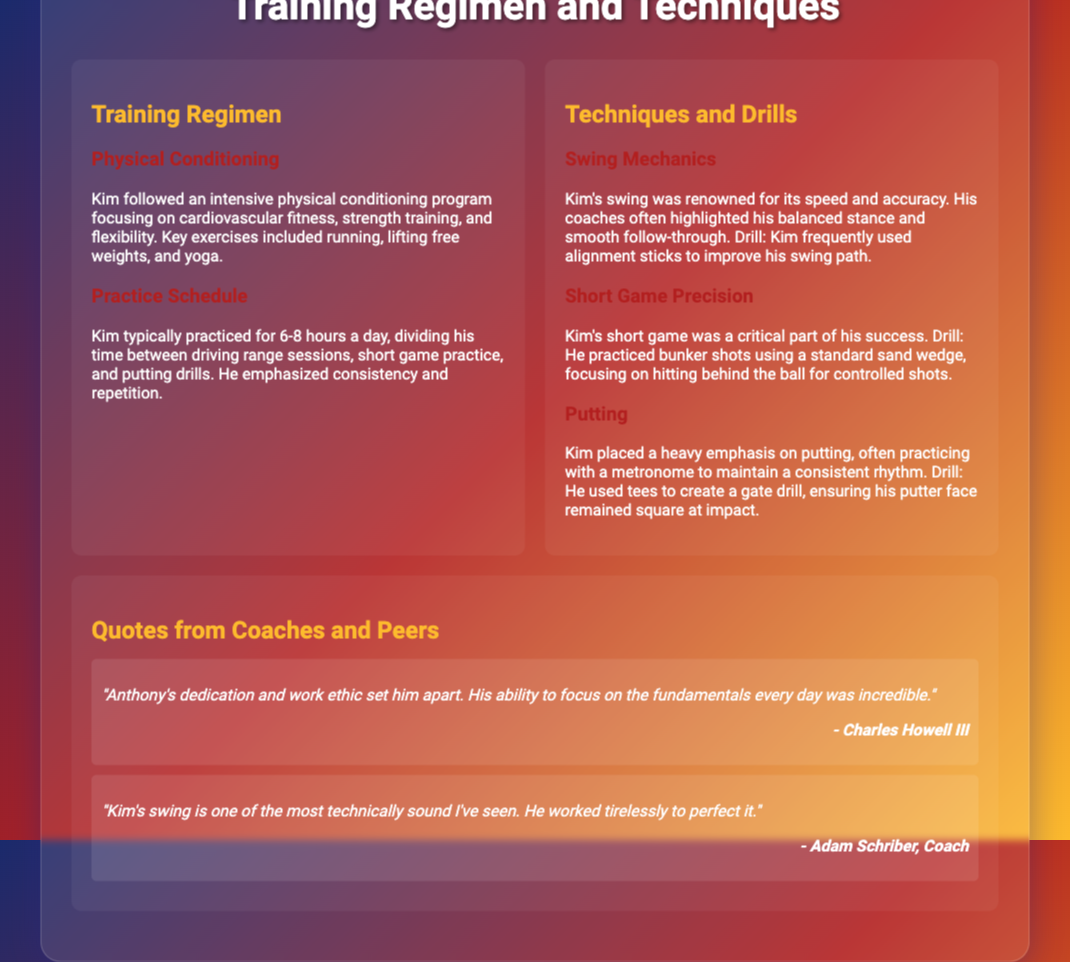What was the focus of Kim's physical conditioning program? The physical conditioning program focused on cardiovascular fitness, strength training, and flexibility.
Answer: Cardiovascular fitness, strength training, and flexibility How many hours did Kim typically practice in a day? Kim typically practiced for 6-8 hours a day.
Answer: 6-8 hours What technique did Kim frequently use to improve his swing path? Kim frequently used alignment sticks to improve his swing path.
Answer: Alignment sticks What is a critical part of Kim's game according to the document? The short game was a critical part of Kim's success.
Answer: Short game Who mentioned Anthony's dedication and work ethic? Charles Howell III mentioned Anthony's dedication and work ethic.
Answer: Charles Howell III 